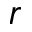<formula> <loc_0><loc_0><loc_500><loc_500>r</formula> 